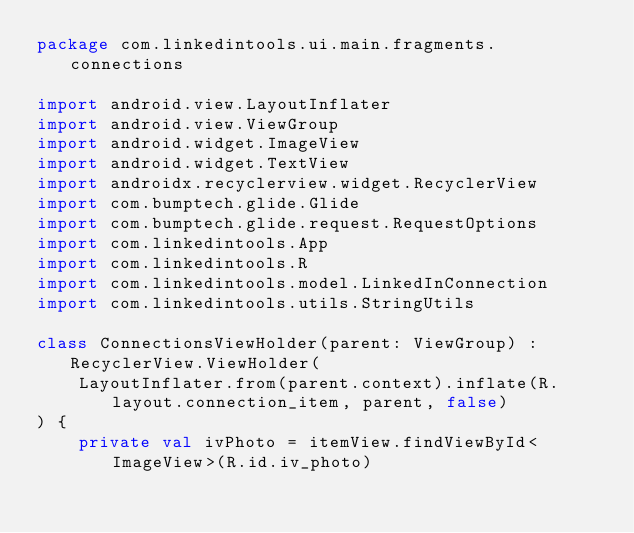Convert code to text. <code><loc_0><loc_0><loc_500><loc_500><_Kotlin_>package com.linkedintools.ui.main.fragments.connections

import android.view.LayoutInflater
import android.view.ViewGroup
import android.widget.ImageView
import android.widget.TextView
import androidx.recyclerview.widget.RecyclerView
import com.bumptech.glide.Glide
import com.bumptech.glide.request.RequestOptions
import com.linkedintools.App
import com.linkedintools.R
import com.linkedintools.model.LinkedInConnection
import com.linkedintools.utils.StringUtils

class ConnectionsViewHolder(parent: ViewGroup) : RecyclerView.ViewHolder(
    LayoutInflater.from(parent.context).inflate(R.layout.connection_item, parent, false)
) {
    private val ivPhoto = itemView.findViewById<ImageView>(R.id.iv_photo)</code> 